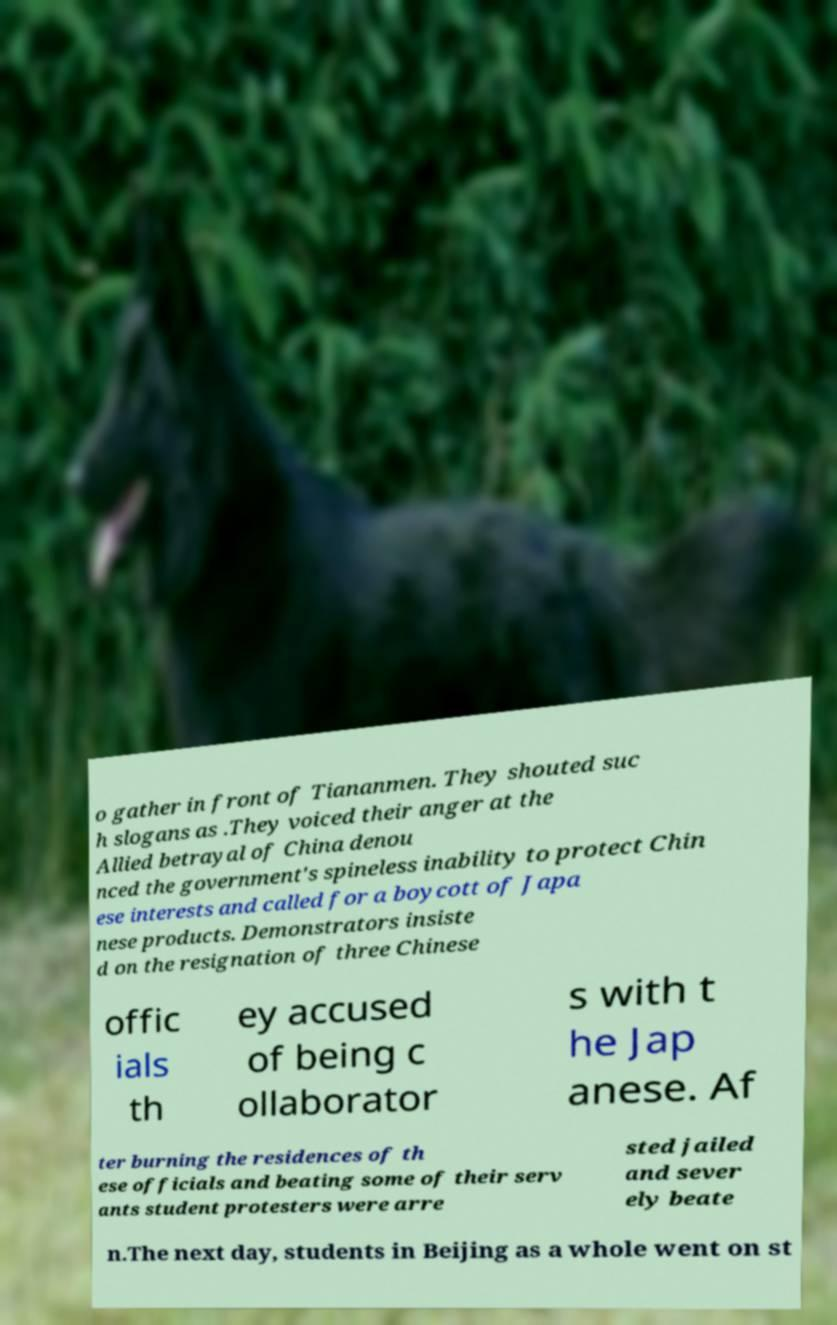Can you read and provide the text displayed in the image?This photo seems to have some interesting text. Can you extract and type it out for me? o gather in front of Tiananmen. They shouted suc h slogans as .They voiced their anger at the Allied betrayal of China denou nced the government's spineless inability to protect Chin ese interests and called for a boycott of Japa nese products. Demonstrators insiste d on the resignation of three Chinese offic ials th ey accused of being c ollaborator s with t he Jap anese. Af ter burning the residences of th ese officials and beating some of their serv ants student protesters were arre sted jailed and sever ely beate n.The next day, students in Beijing as a whole went on st 